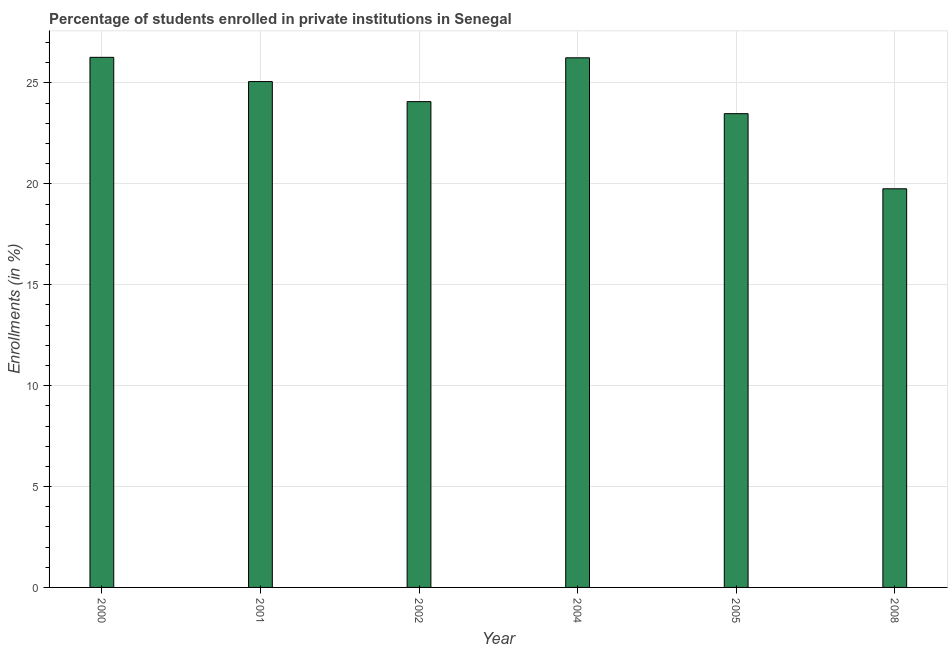Does the graph contain any zero values?
Your answer should be very brief. No. What is the title of the graph?
Provide a succinct answer. Percentage of students enrolled in private institutions in Senegal. What is the label or title of the X-axis?
Keep it short and to the point. Year. What is the label or title of the Y-axis?
Your answer should be very brief. Enrollments (in %). What is the enrollments in private institutions in 2000?
Provide a succinct answer. 26.27. Across all years, what is the maximum enrollments in private institutions?
Give a very brief answer. 26.27. Across all years, what is the minimum enrollments in private institutions?
Provide a succinct answer. 19.76. What is the sum of the enrollments in private institutions?
Ensure brevity in your answer.  144.9. What is the difference between the enrollments in private institutions in 2004 and 2005?
Your answer should be very brief. 2.77. What is the average enrollments in private institutions per year?
Keep it short and to the point. 24.15. What is the median enrollments in private institutions?
Your answer should be compact. 24.57. What is the ratio of the enrollments in private institutions in 2001 to that in 2005?
Make the answer very short. 1.07. Is the enrollments in private institutions in 2001 less than that in 2004?
Your response must be concise. Yes. Is the difference between the enrollments in private institutions in 2005 and 2008 greater than the difference between any two years?
Provide a short and direct response. No. What is the difference between the highest and the second highest enrollments in private institutions?
Your answer should be very brief. 0.02. What is the difference between the highest and the lowest enrollments in private institutions?
Your answer should be very brief. 6.51. In how many years, is the enrollments in private institutions greater than the average enrollments in private institutions taken over all years?
Offer a terse response. 3. Are all the bars in the graph horizontal?
Your answer should be compact. No. How many years are there in the graph?
Make the answer very short. 6. Are the values on the major ticks of Y-axis written in scientific E-notation?
Ensure brevity in your answer.  No. What is the Enrollments (in %) in 2000?
Ensure brevity in your answer.  26.27. What is the Enrollments (in %) in 2001?
Your answer should be compact. 25.07. What is the Enrollments (in %) of 2002?
Your answer should be compact. 24.08. What is the Enrollments (in %) of 2004?
Make the answer very short. 26.25. What is the Enrollments (in %) in 2005?
Provide a short and direct response. 23.48. What is the Enrollments (in %) in 2008?
Your answer should be very brief. 19.76. What is the difference between the Enrollments (in %) in 2000 and 2001?
Your answer should be compact. 1.2. What is the difference between the Enrollments (in %) in 2000 and 2002?
Provide a short and direct response. 2.2. What is the difference between the Enrollments (in %) in 2000 and 2004?
Your response must be concise. 0.02. What is the difference between the Enrollments (in %) in 2000 and 2005?
Make the answer very short. 2.79. What is the difference between the Enrollments (in %) in 2000 and 2008?
Keep it short and to the point. 6.51. What is the difference between the Enrollments (in %) in 2001 and 2002?
Make the answer very short. 0.99. What is the difference between the Enrollments (in %) in 2001 and 2004?
Ensure brevity in your answer.  -1.18. What is the difference between the Enrollments (in %) in 2001 and 2005?
Provide a short and direct response. 1.59. What is the difference between the Enrollments (in %) in 2001 and 2008?
Offer a terse response. 5.31. What is the difference between the Enrollments (in %) in 2002 and 2004?
Provide a short and direct response. -2.17. What is the difference between the Enrollments (in %) in 2002 and 2005?
Your answer should be compact. 0.6. What is the difference between the Enrollments (in %) in 2002 and 2008?
Your response must be concise. 4.32. What is the difference between the Enrollments (in %) in 2004 and 2005?
Your answer should be compact. 2.77. What is the difference between the Enrollments (in %) in 2004 and 2008?
Give a very brief answer. 6.49. What is the difference between the Enrollments (in %) in 2005 and 2008?
Your answer should be compact. 3.72. What is the ratio of the Enrollments (in %) in 2000 to that in 2001?
Make the answer very short. 1.05. What is the ratio of the Enrollments (in %) in 2000 to that in 2002?
Keep it short and to the point. 1.09. What is the ratio of the Enrollments (in %) in 2000 to that in 2005?
Provide a short and direct response. 1.12. What is the ratio of the Enrollments (in %) in 2000 to that in 2008?
Make the answer very short. 1.33. What is the ratio of the Enrollments (in %) in 2001 to that in 2002?
Provide a succinct answer. 1.04. What is the ratio of the Enrollments (in %) in 2001 to that in 2004?
Provide a succinct answer. 0.95. What is the ratio of the Enrollments (in %) in 2001 to that in 2005?
Your answer should be very brief. 1.07. What is the ratio of the Enrollments (in %) in 2001 to that in 2008?
Your answer should be very brief. 1.27. What is the ratio of the Enrollments (in %) in 2002 to that in 2004?
Offer a very short reply. 0.92. What is the ratio of the Enrollments (in %) in 2002 to that in 2005?
Your answer should be compact. 1.02. What is the ratio of the Enrollments (in %) in 2002 to that in 2008?
Offer a terse response. 1.22. What is the ratio of the Enrollments (in %) in 2004 to that in 2005?
Your response must be concise. 1.12. What is the ratio of the Enrollments (in %) in 2004 to that in 2008?
Make the answer very short. 1.33. What is the ratio of the Enrollments (in %) in 2005 to that in 2008?
Provide a short and direct response. 1.19. 